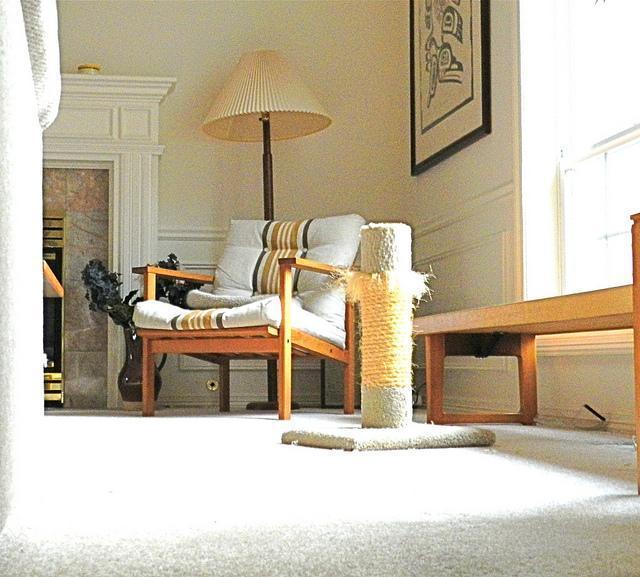How many potted plants are there?
Give a very brief answer. 1. 